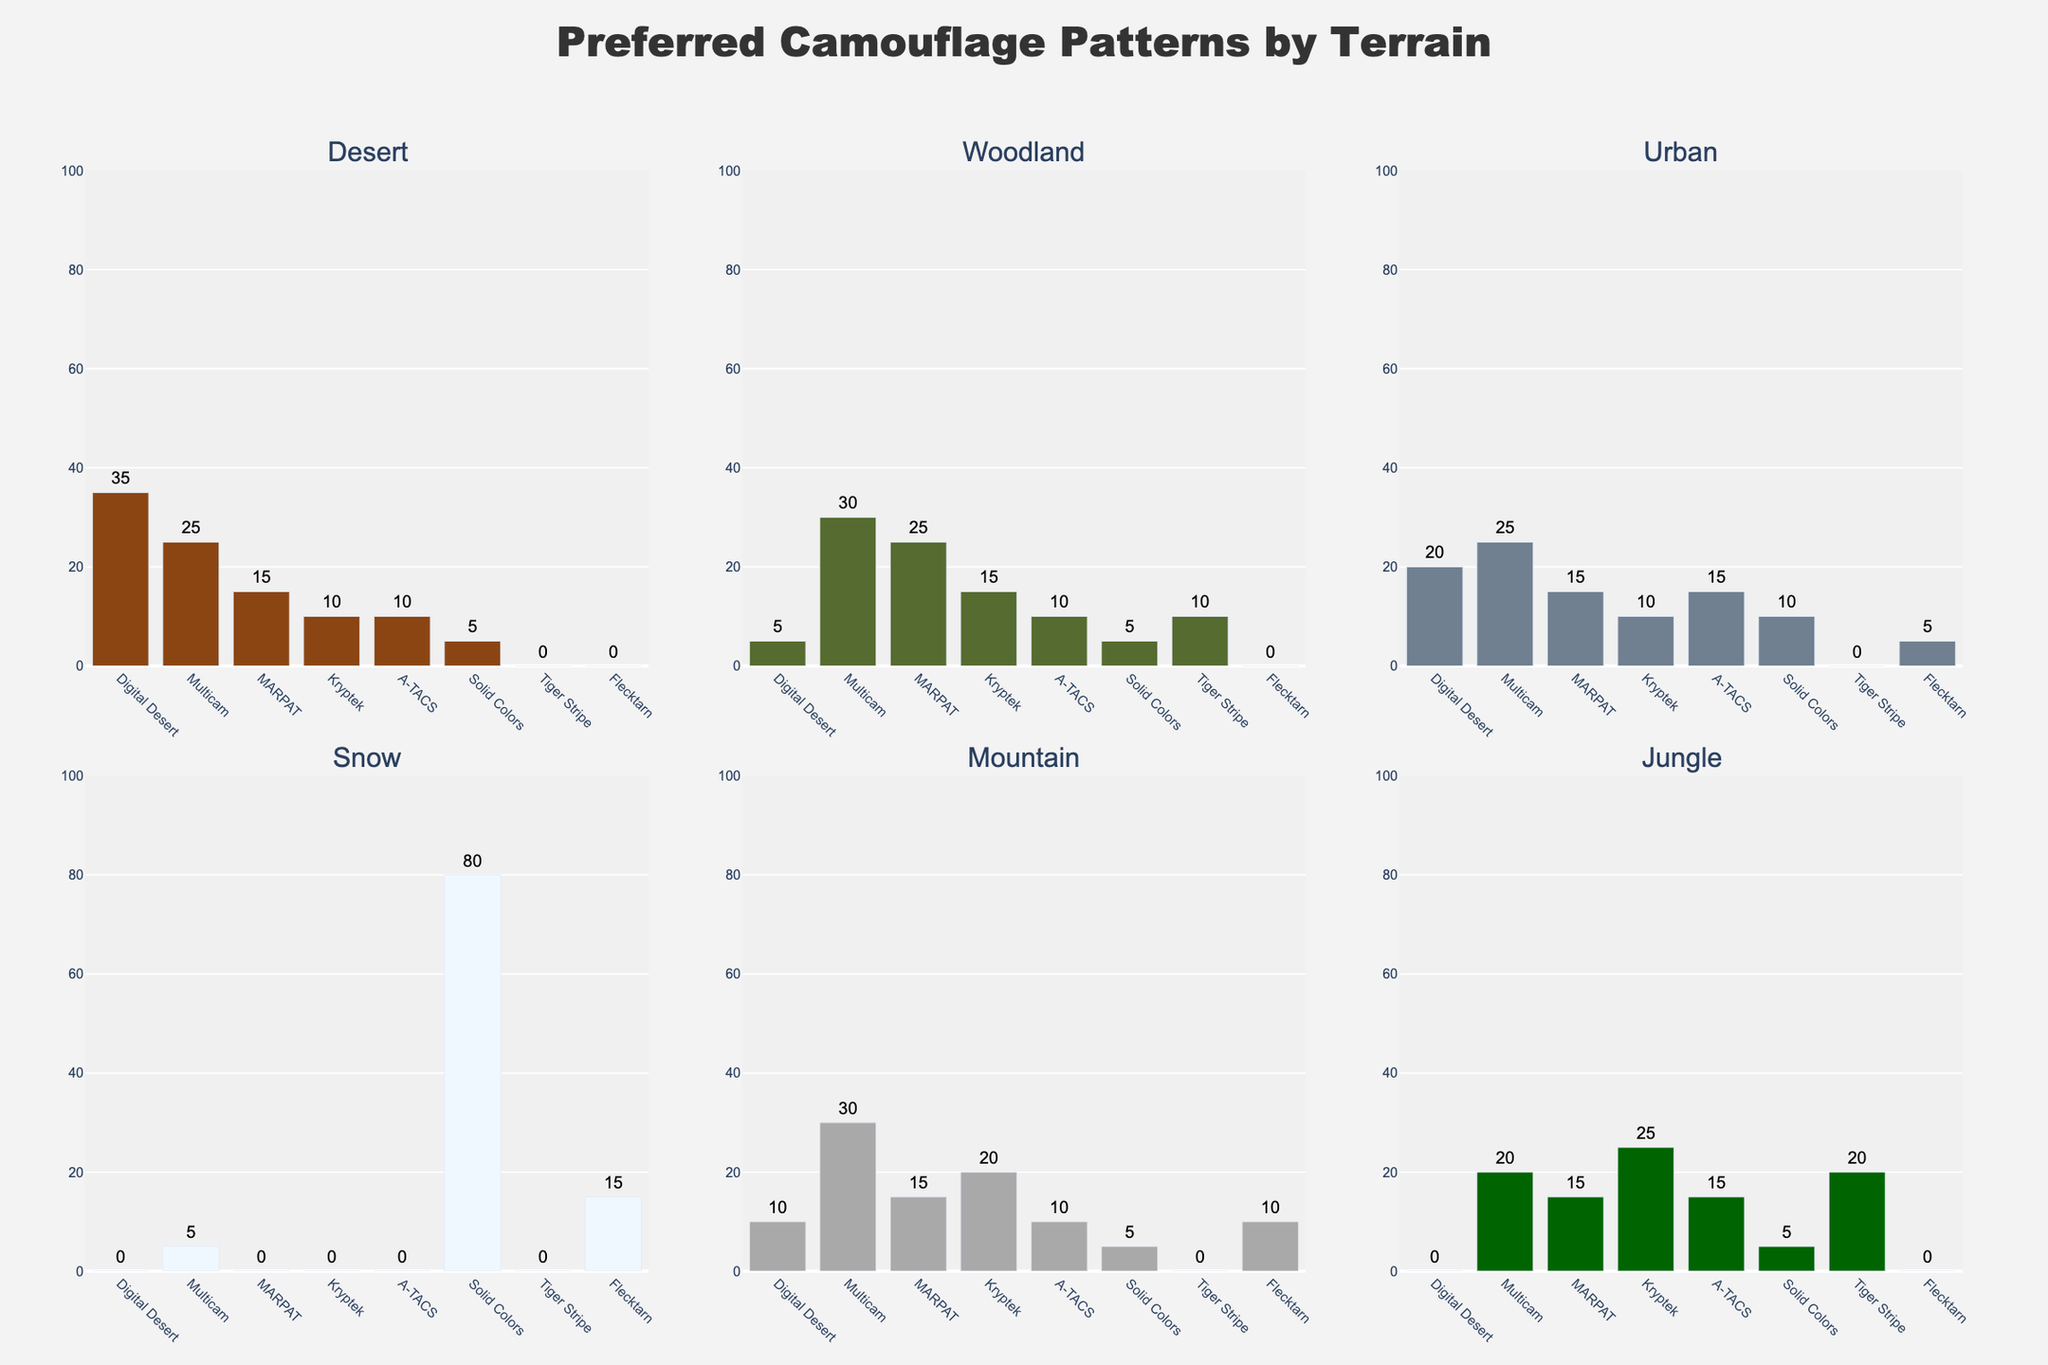What's the most preferred camouflage pattern in the Snow terrain? Look at the bar chart corresponding to the Snow terrain. The pattern with the highest bar represents the most preferred camouflage. The highest bar is for Solid Colors with 80%.
Answer: Solid Colors Which camouflage pattern is least preferred in the Desert terrain? Check the bar chart for the Desert terrain. The pattern with the shortest bar is the least preferred. Tiger Stripe and Flecktarn have the shortest bars at 0%.
Answer: Tiger Stripe, Flecktarn What’s the combined preference percentage for the Digital Desert and Multicam patterns in the Mountain terrain? In the Mountain terrain chart, find the heights for Digital Desert (10%) and Multicam (30%). Add them up: 10% + 30% = 40%.
Answer: 40% Which terrain shows the highest preference percentage for Kryptek patterns? Compare the bars for Kryptek patterns across all terrain charts. The tallest bar is in the Jungle terrain at 25%.
Answer: Jungle How does the preference for MARPAT compare between Woodland and Urban terrains? Check the bars for MARPAT in Woodland (25%) and Urban (15%) terrains. Subtract the smaller percentage from the larger one: 25% - 15% = 10%.
Answer: MARPAT is preferred 10% more in Woodland compared to Urban Which camouflage patterns have no preference in the Urban terrain? In the Urban terrain chart, look for bars with a height of 0%. Digital Desert, MARPAT, and Tiger Stripe have zero height bars.
Answer: Digital Desert, MARPAT, Tiger Stripe What percentage of preference does the least popular pattern in the Mountain terrain receive? In the Mountain terrain chart, the shortest bars indicate the least popular patterns. Digital Desert and Solid Colors both have the shortest bars at 5%.
Answer: 5% Which pattern shows the most significant difference in preference between the Desert and Jungle terrains? Compare the differences in heights for each pattern. Digital Desert has 35% in Desert and 0% in Jungle, resulting in a difference of 35%.
Answer: Digital Desert What is the average preference for A-TACS patterns across Desert, Woodland, and Urban terrains? Find the heights for A-TACS in Desert (10%), Woodland (10%), and Urban (15%). Calculate the average: (10% + 10% + 15%) / 3 = 11.67%.
Answer: 11.67% Between Multicam and Flecktarn, which has a higher preference in the Snow terrain, and by how much? Compare the bars in the Snow terrain. Multicam has 5%, and Flecktarn has 15%. Calculate the difference: 15% - 5% = 10%.
Answer: Flecktarn by 10% 